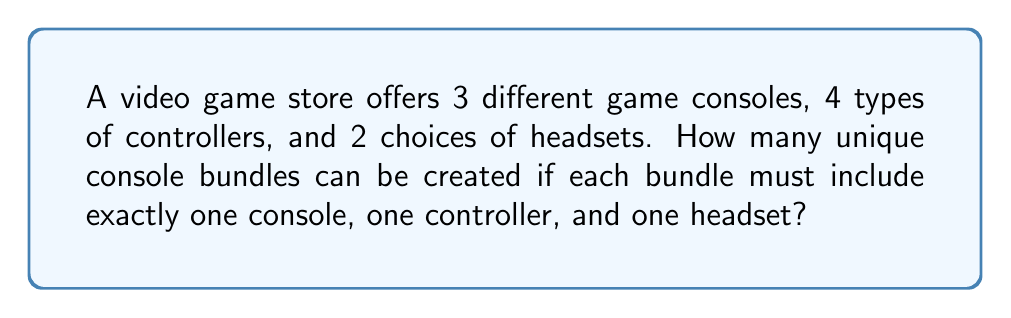Can you answer this question? Let's approach this step-by-step using the multiplication principle of counting:

1) For each bundle, we need to choose:
   - One console out of 3 options
   - One controller out of 4 options
   - One headset out of 2 options

2) According to the multiplication principle, if we have a series of independent choices, the total number of possible outcomes is the product of the number of possibilities for each choice.

3) Therefore, the total number of unique bundles is:

   $$ 3 \times 4 \times 2 $$

4) Calculating this:
   $$ 3 \times 4 \times 2 = 24 $$

Thus, there are 24 possible unique console bundles that can be created.
Answer: 24 